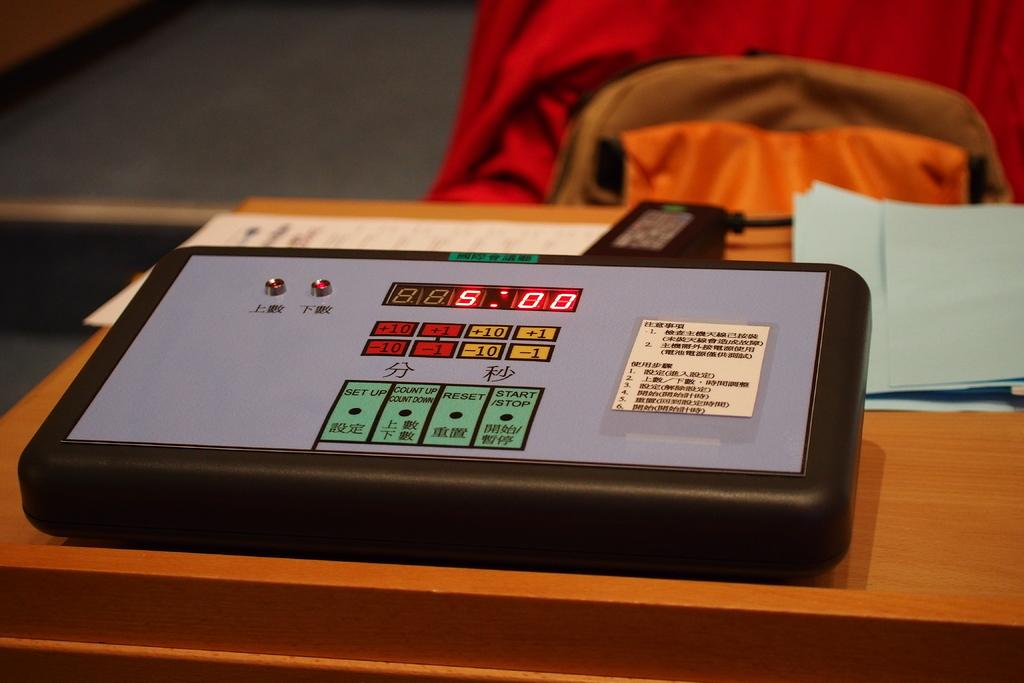What object is on the table in the image? There is an electronic machine on the table. What is located near the electronic machine? There is a charger beside the electronic machine. What can be seen on the right side of the table? There are papers on the right side of the table. What can be seen in the background of the image? There are clothes visible in the background. Can you tell me the weight of the porter in the image? There is no porter present in the image, so it is not possible to determine their weight. 